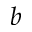<formula> <loc_0><loc_0><loc_500><loc_500>b</formula> 